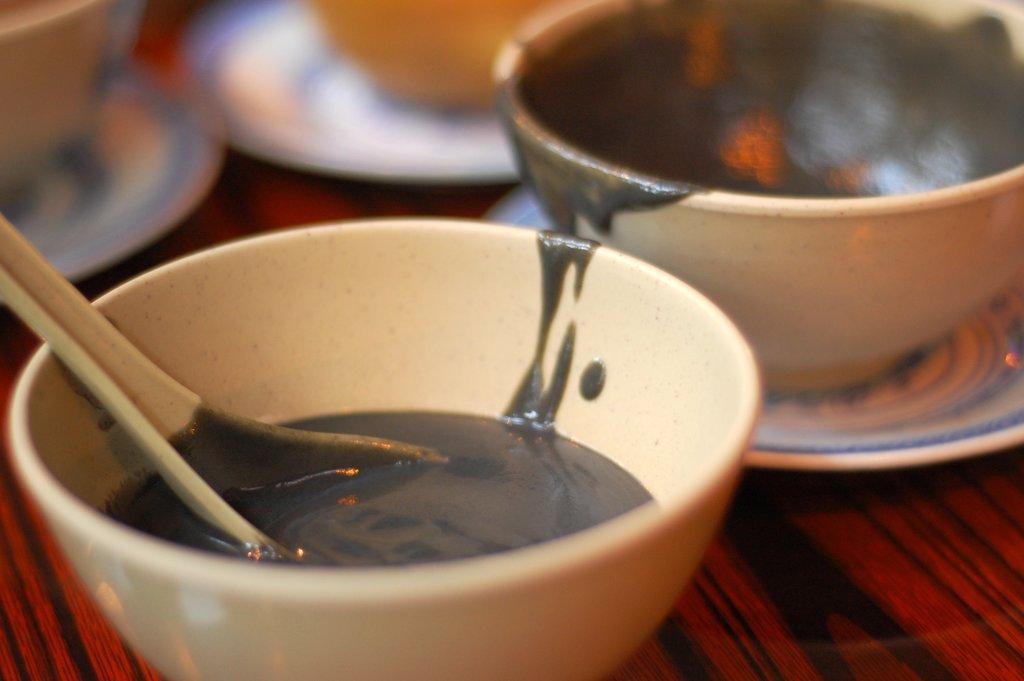Describe this image in one or two sentences. In this image i can see there are two cups on the table. 